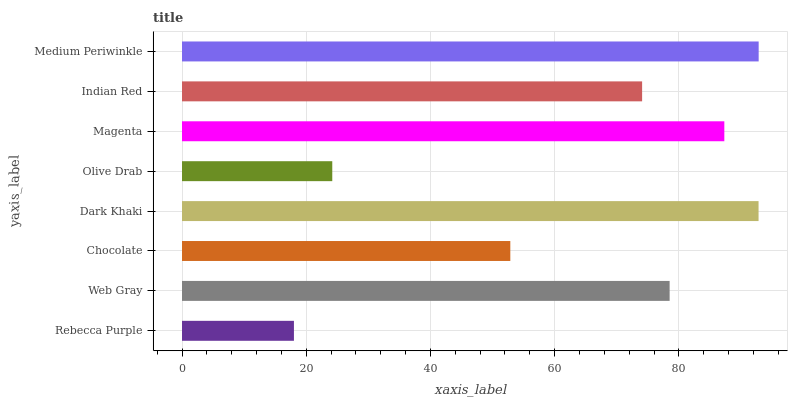Is Rebecca Purple the minimum?
Answer yes or no. Yes. Is Medium Periwinkle the maximum?
Answer yes or no. Yes. Is Web Gray the minimum?
Answer yes or no. No. Is Web Gray the maximum?
Answer yes or no. No. Is Web Gray greater than Rebecca Purple?
Answer yes or no. Yes. Is Rebecca Purple less than Web Gray?
Answer yes or no. Yes. Is Rebecca Purple greater than Web Gray?
Answer yes or no. No. Is Web Gray less than Rebecca Purple?
Answer yes or no. No. Is Web Gray the high median?
Answer yes or no. Yes. Is Indian Red the low median?
Answer yes or no. Yes. Is Dark Khaki the high median?
Answer yes or no. No. Is Medium Periwinkle the low median?
Answer yes or no. No. 